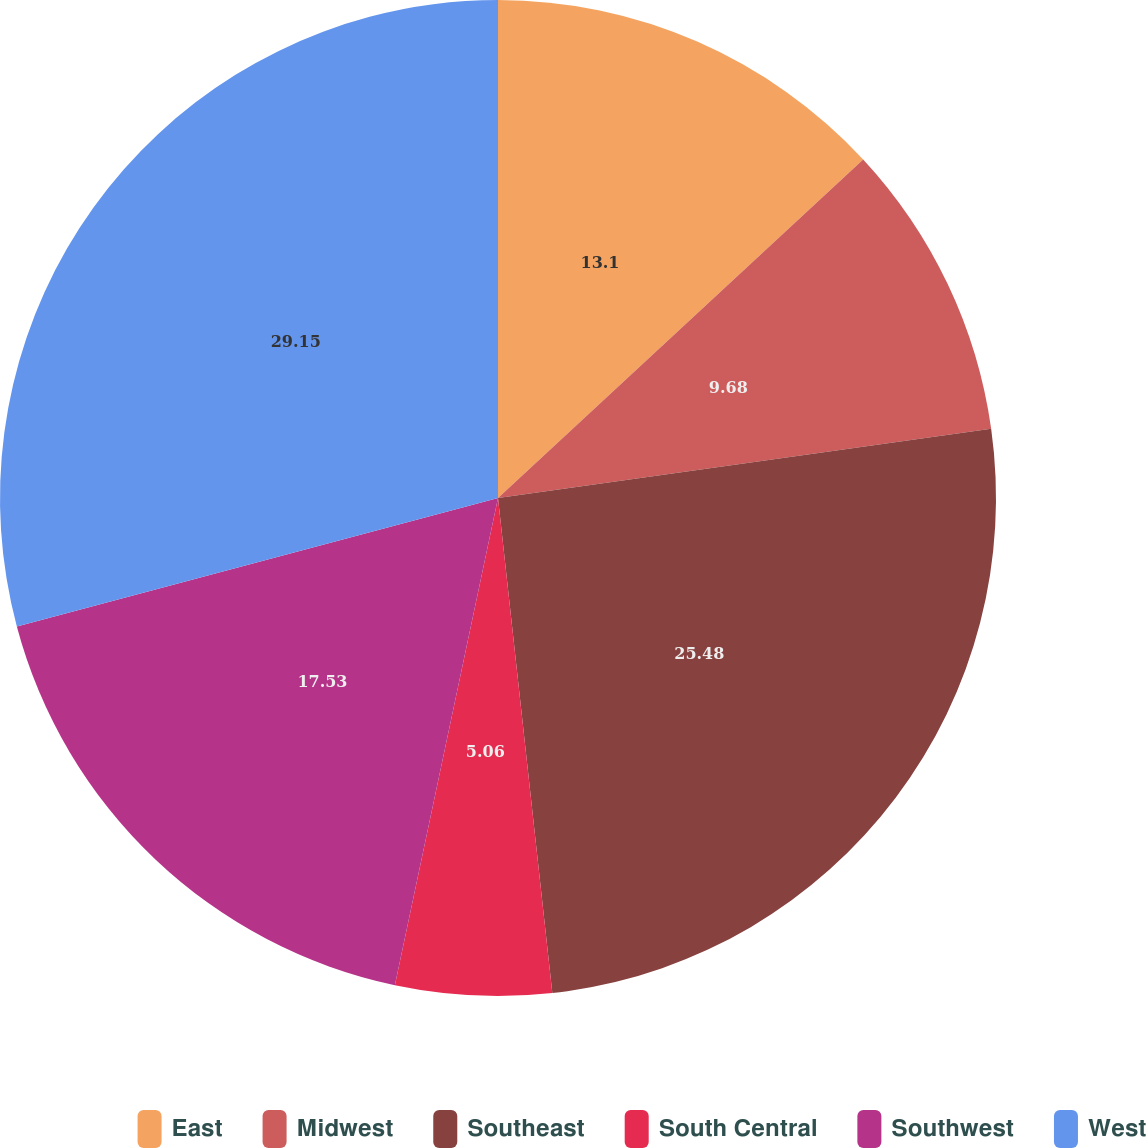<chart> <loc_0><loc_0><loc_500><loc_500><pie_chart><fcel>East<fcel>Midwest<fcel>Southeast<fcel>South Central<fcel>Southwest<fcel>West<nl><fcel>13.1%<fcel>9.68%<fcel>25.48%<fcel>5.06%<fcel>17.53%<fcel>29.15%<nl></chart> 